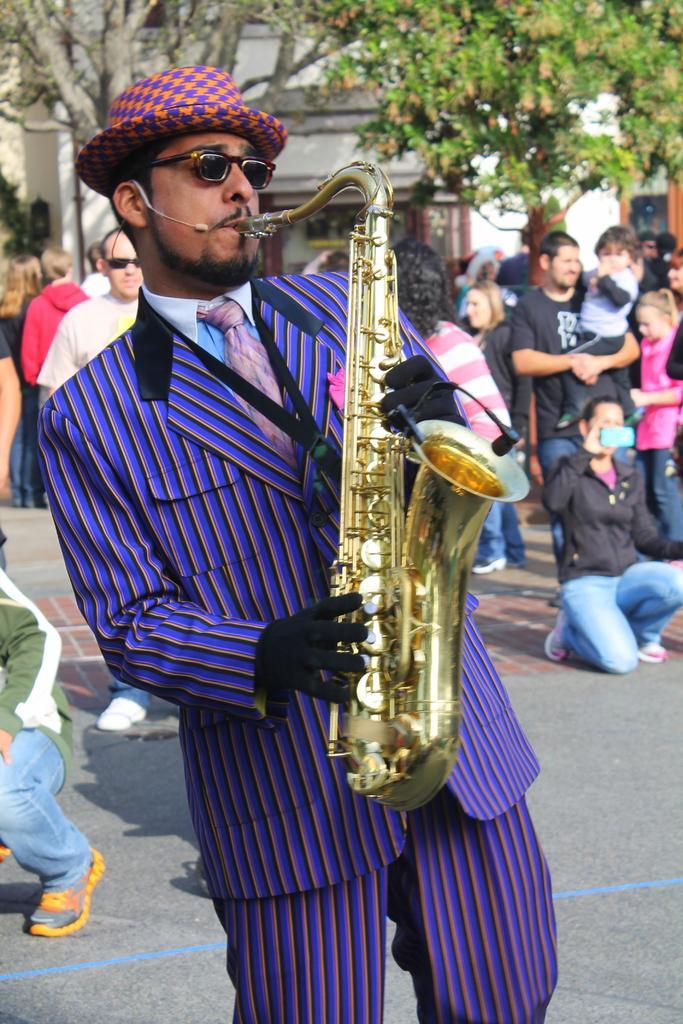Describe this image in one or two sentences. In this image I can see a man is playing the saxophone, he is wearing a coat, tie, shirt, trouser, hat. On the right side a group of people are there, at the back side there are trees and walls. 